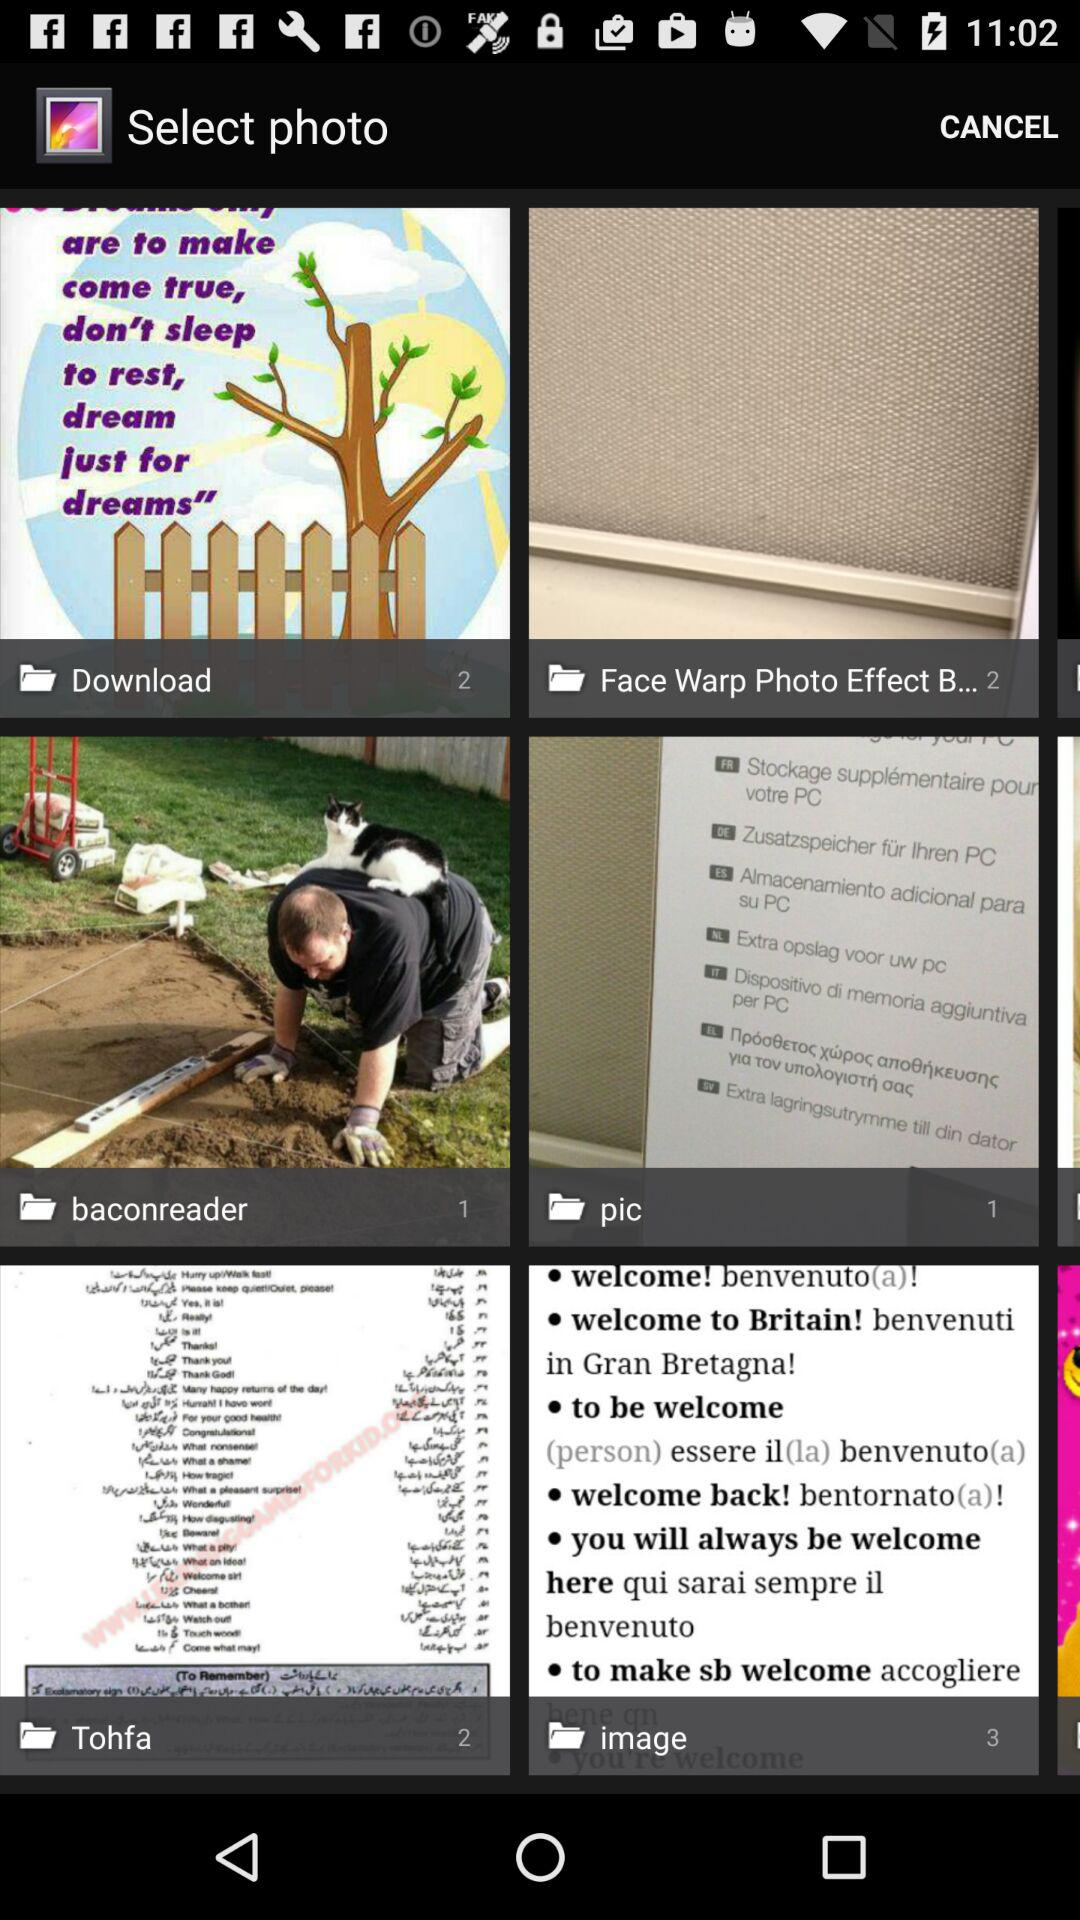What is the count of photos in the "image" folder? The count of photos is 3. 